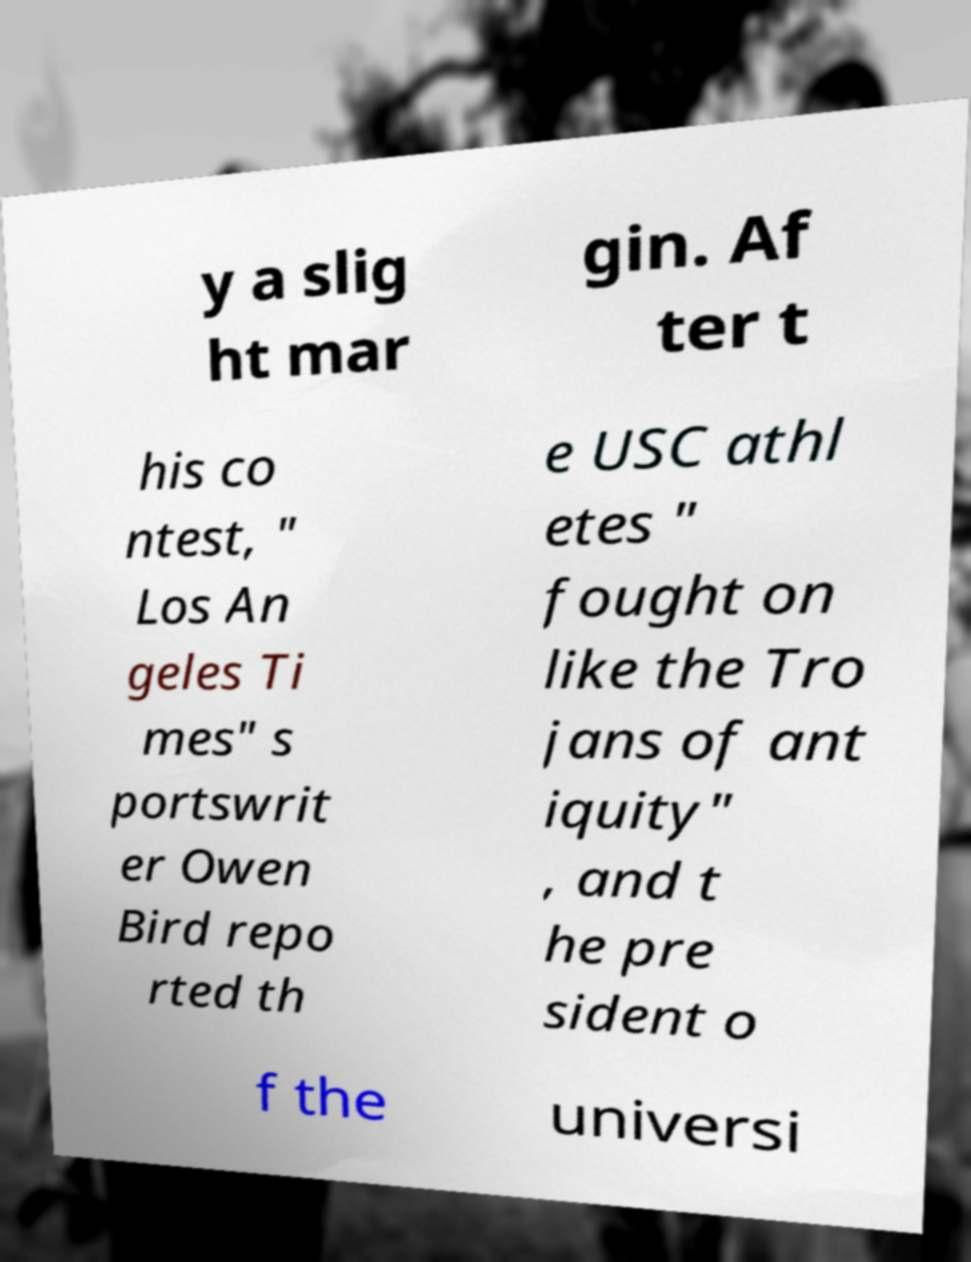Could you assist in decoding the text presented in this image and type it out clearly? y a slig ht mar gin. Af ter t his co ntest, " Los An geles Ti mes" s portswrit er Owen Bird repo rted th e USC athl etes " fought on like the Tro jans of ant iquity" , and t he pre sident o f the universi 